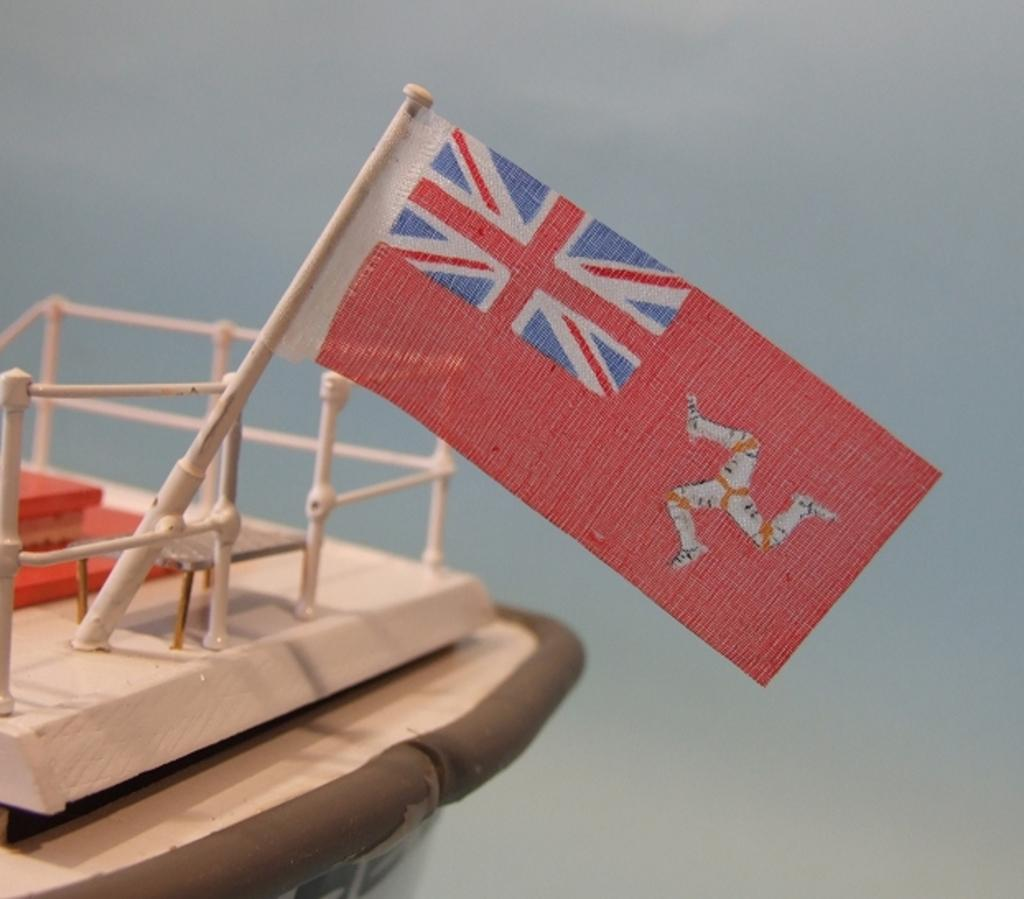What is on the toy ship in the image? There is a flag on the toy ship in the image. Can you describe the background of the image? The background of the image is blurry. What type of trousers is the flag wearing in the image? Flags do not wear trousers, as they are inanimate objects. The question is not relevant to the image. 